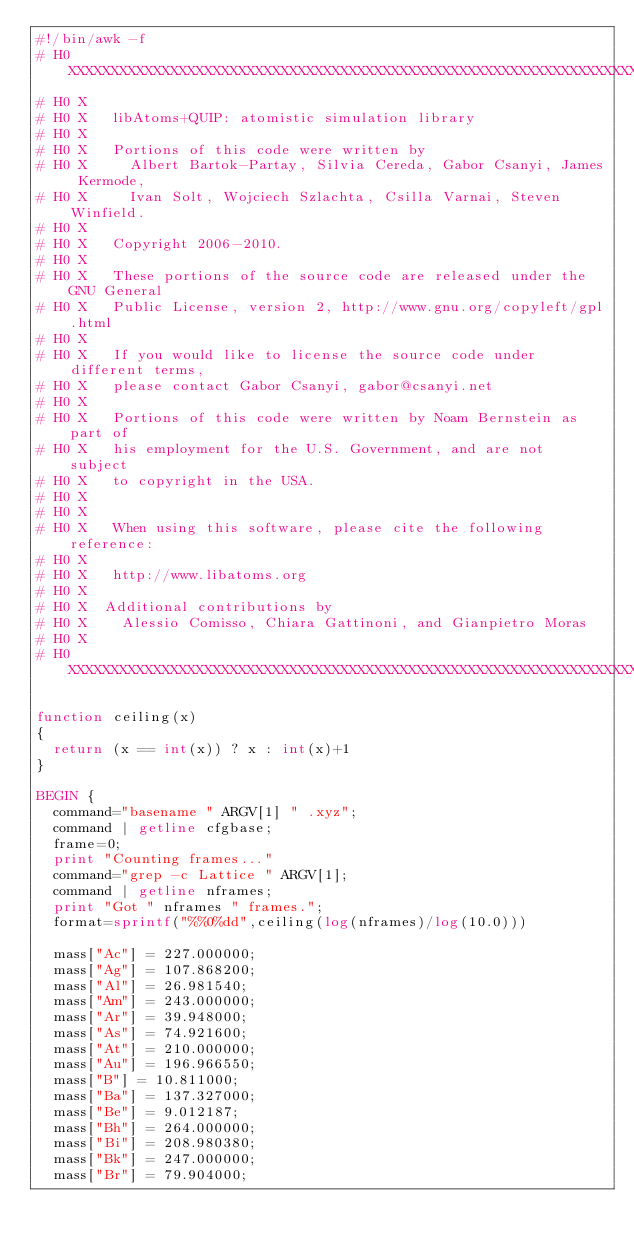Convert code to text. <code><loc_0><loc_0><loc_500><loc_500><_Awk_>#!/bin/awk -f
# H0 XXXXXXXXXXXXXXXXXXXXXXXXXXXXXXXXXXXXXXXXXXXXXXXXXXXXXXXXXXXXXXXXXXXXXXXXXXXX
# H0 X
# H0 X   libAtoms+QUIP: atomistic simulation library
# H0 X
# H0 X   Portions of this code were written by
# H0 X     Albert Bartok-Partay, Silvia Cereda, Gabor Csanyi, James Kermode,
# H0 X     Ivan Solt, Wojciech Szlachta, Csilla Varnai, Steven Winfield.
# H0 X
# H0 X   Copyright 2006-2010.
# H0 X
# H0 X   These portions of the source code are released under the GNU General
# H0 X   Public License, version 2, http://www.gnu.org/copyleft/gpl.html
# H0 X
# H0 X   If you would like to license the source code under different terms,
# H0 X   please contact Gabor Csanyi, gabor@csanyi.net
# H0 X
# H0 X   Portions of this code were written by Noam Bernstein as part of
# H0 X   his employment for the U.S. Government, and are not subject
# H0 X   to copyright in the USA.
# H0 X
# H0 X
# H0 X   When using this software, please cite the following reference:
# H0 X
# H0 X   http://www.libatoms.org
# H0 X
# H0 X  Additional contributions by
# H0 X    Alessio Comisso, Chiara Gattinoni, and Gianpietro Moras
# H0 X
# H0 XXXXXXXXXXXXXXXXXXXXXXXXXXXXXXXXXXXXXXXXXXXXXXXXXXXXXXXXXXXXXXXXXXXXXXXXXXXX

function ceiling(x)
{
  return (x == int(x)) ? x : int(x)+1
}

BEGIN {
  command="basename " ARGV[1] " .xyz";
  command | getline cfgbase;
  frame=0;
  print "Counting frames..."
  command="grep -c Lattice " ARGV[1];
  command | getline nframes;
  print "Got " nframes " frames.";
  format=sprintf("%%0%dd",ceiling(log(nframes)/log(10.0)))

  mass["Ac"] = 227.000000;
  mass["Ag"] = 107.868200;
  mass["Al"] = 26.981540;
  mass["Am"] = 243.000000;
  mass["Ar"] = 39.948000;
  mass["As"] = 74.921600;
  mass["At"] = 210.000000;
  mass["Au"] = 196.966550;
  mass["B"] = 10.811000;
  mass["Ba"] = 137.327000;
  mass["Be"] = 9.012187;
  mass["Bh"] = 264.000000;
  mass["Bi"] = 208.980380;
  mass["Bk"] = 247.000000;
  mass["Br"] = 79.904000;</code> 